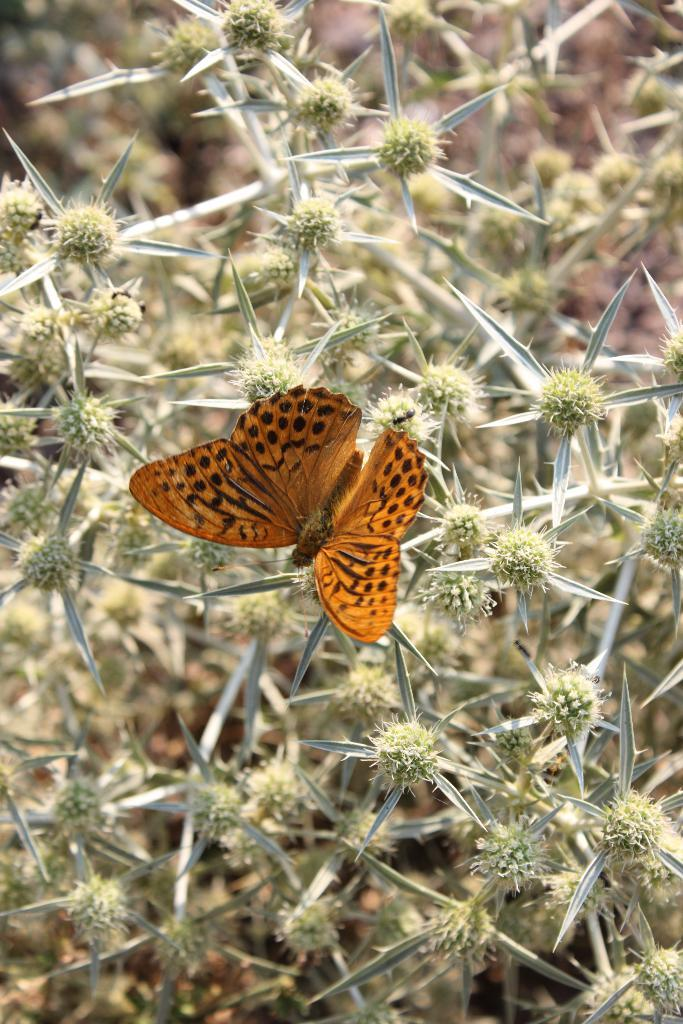What type of insect is in the image? There is an orange color butterfly in the image. Where is the butterfly located? The butterfly is standing on a branch of a plant. What can be observed about the plant in the image? The plant has leaves and fruits. How would you describe the background of the image? The background of the image is blurred. What type of bun is covering the plant in the image? There is no bun present in the image, and it is not covering the plant. How can you tell if the butterfly is quiet in the image? The image does not provide any information about the butterfly's sound or level of noise. 